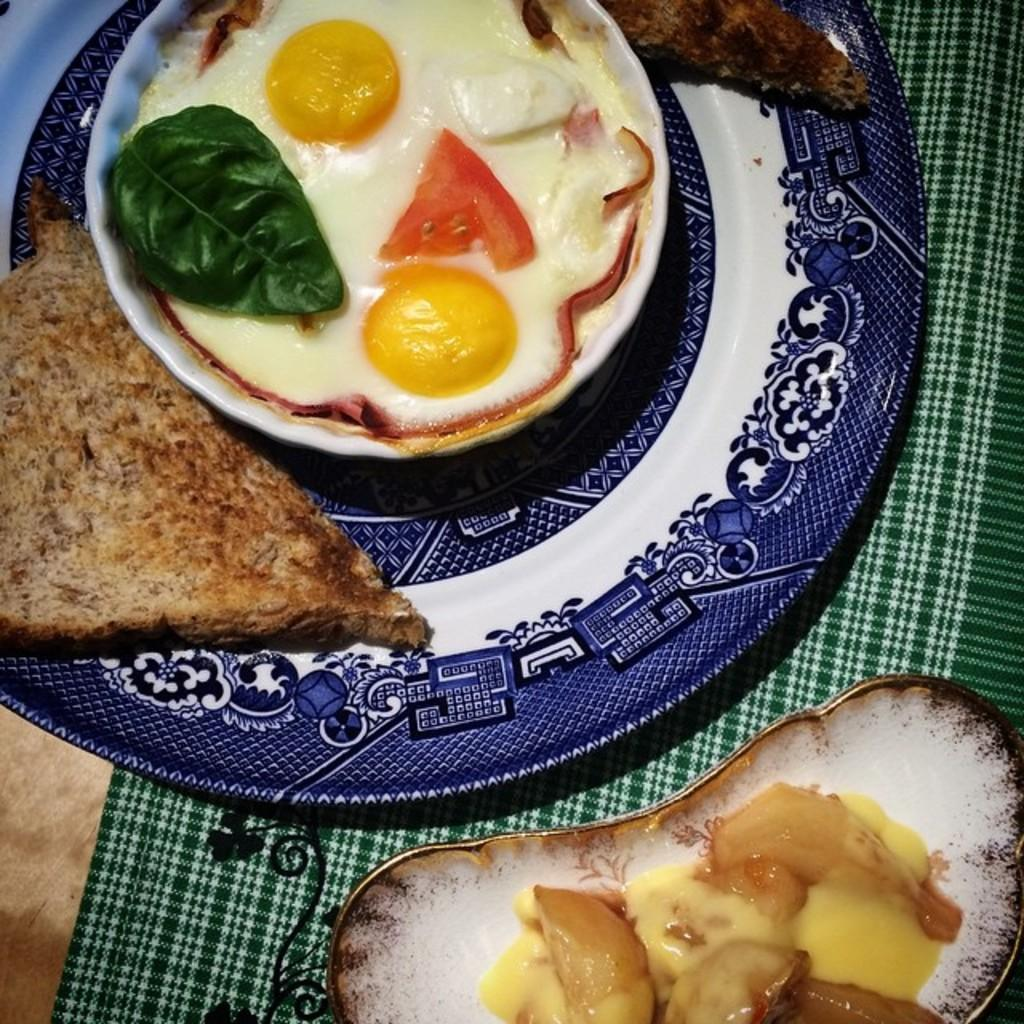What type of dishware can be seen in the image? There is a plate and bowls in the image. What is placed on the dishware? There are food items in the image. On what surface are the plate, bowls, and food items placed? The plate, bowls, and food items are placed on a cloth. Are there any deer visible in the image? No, there are no deer present in the image. Can you see any cobwebs in the image? No, there are no cobwebs visible in the image. 